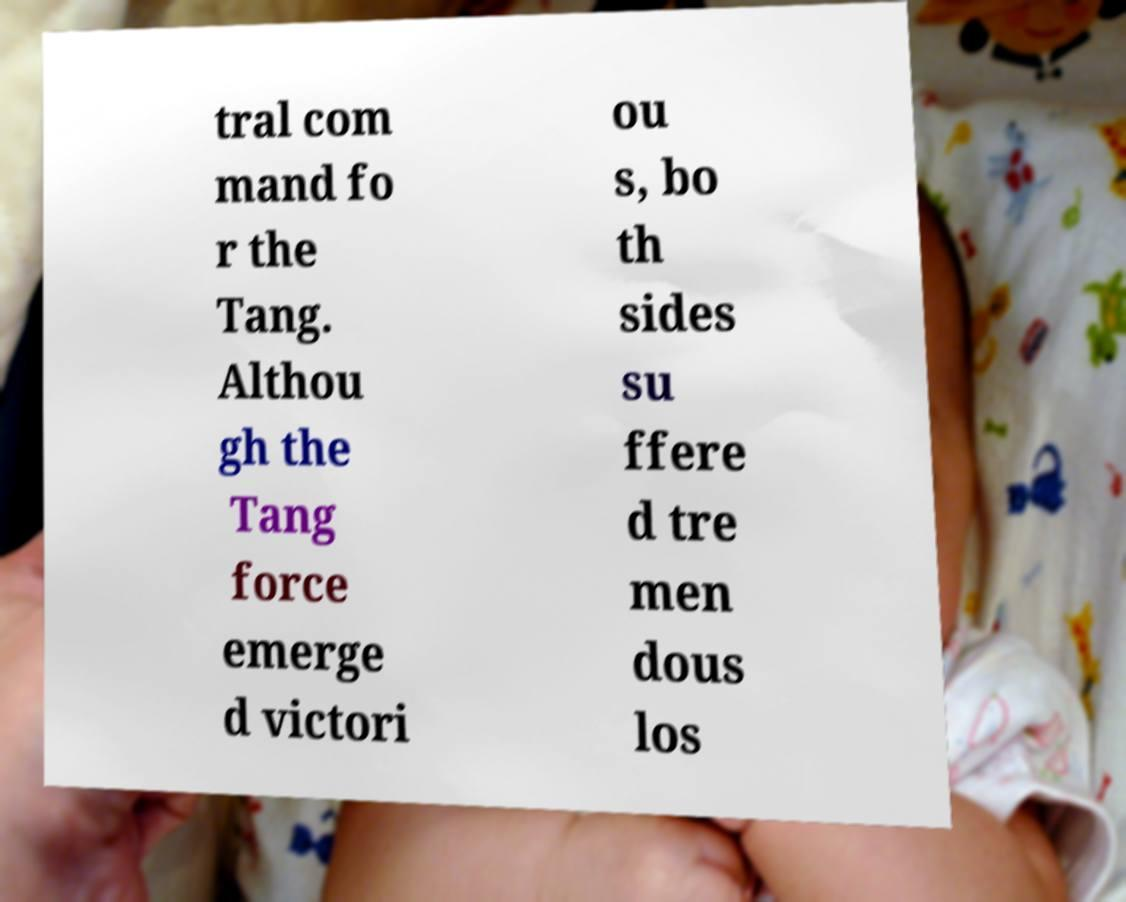Please read and relay the text visible in this image. What does it say? tral com mand fo r the Tang. Althou gh the Tang force emerge d victori ou s, bo th sides su ffere d tre men dous los 